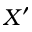Convert formula to latex. <formula><loc_0><loc_0><loc_500><loc_500>X ^ { \prime }</formula> 